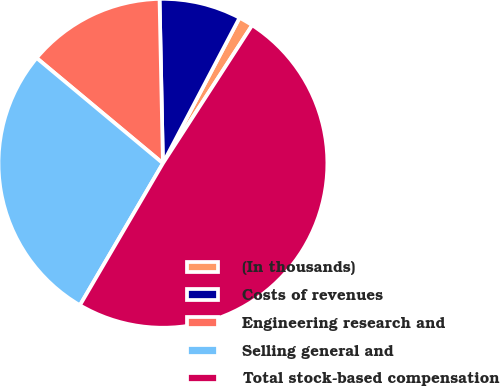Convert chart to OTSL. <chart><loc_0><loc_0><loc_500><loc_500><pie_chart><fcel>(In thousands)<fcel>Costs of revenues<fcel>Engineering research and<fcel>Selling general and<fcel>Total stock-based compensation<nl><fcel>1.42%<fcel>8.04%<fcel>13.61%<fcel>27.64%<fcel>49.29%<nl></chart> 